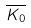<formula> <loc_0><loc_0><loc_500><loc_500>\overline { K _ { 0 } }</formula> 